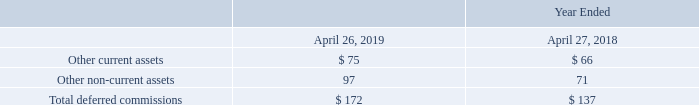Deferred commissions
As a result of our adoption of ASC 606, we capitalize sales commissions that are incremental direct costs of obtaining customer contracts for which revenue is not immediately recognized. We then amortize capitalized commissions based on the transfer of goods or services to which they relate. The following tables summarize the activity related to deferred commissions and their balances as reported in our consolidated balance sheets (in millions):
Why did the company capitalize sales commissions that are incremental direct costs of obtaining customer contracts for which revenue is not immediately recognized? A result of our adoption of asc 606. What was the balance at beginning of period in 2019?
Answer scale should be: million. 137. What does the table show? Summarize the activity related to deferred commissions and their balances as reported in our consolidated balance sheets. What was the change in Other current assets between 2018 and 2019?
Answer scale should be: million. 75-66
Answer: 9. What was the change in Total deferred commissions between 2018 and 2019?
Answer scale should be: million. 172-137
Answer: 35. What was the percentage change in  Total deferred commissions between 2018 and 2019?
Answer scale should be: percent. (172-137)/137
Answer: 25.55. 